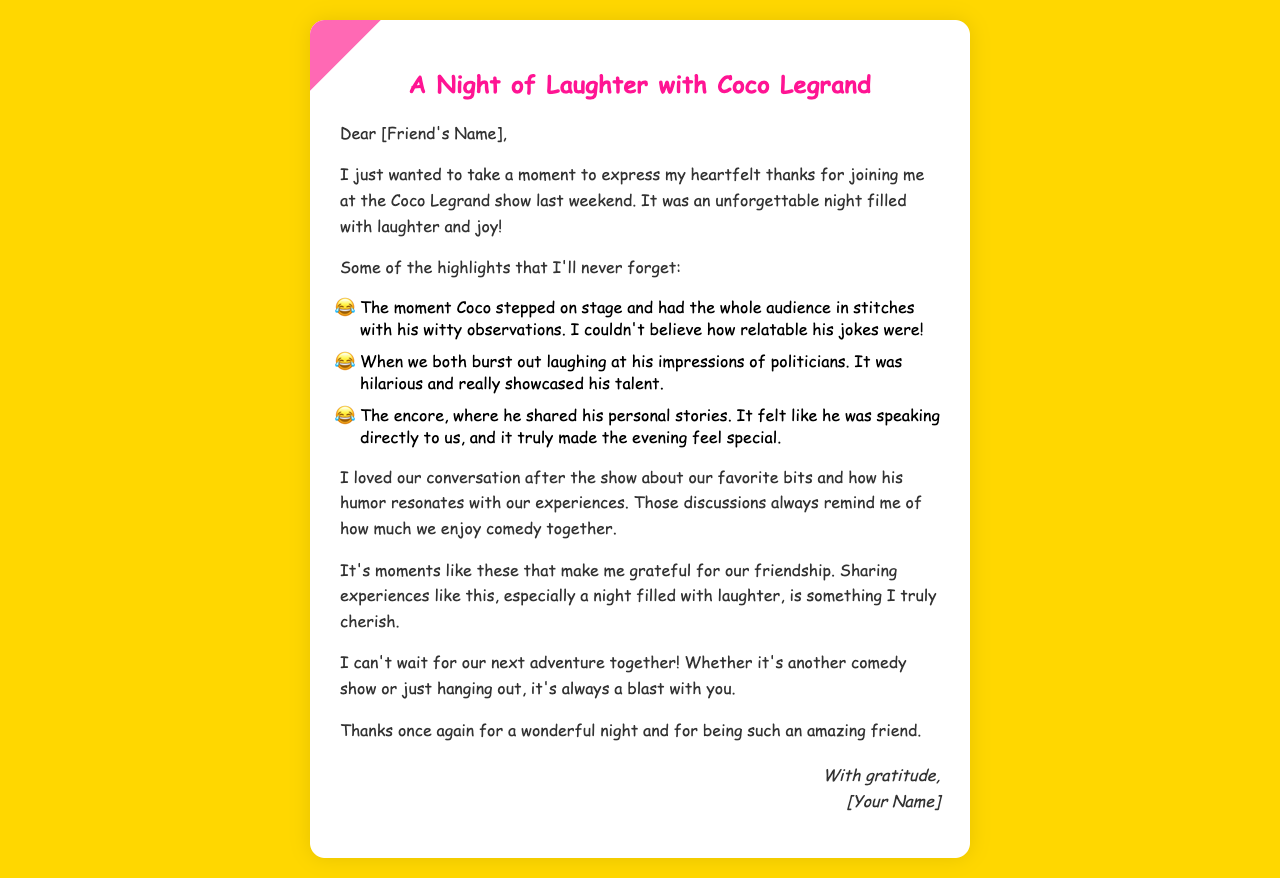What is the title of the letter? The title of the letter is stated at the top of the document.
Answer: A Night of Laughter with Coco Legrand Who is the letter addressed to? The letter is addressed to a specific friend by placeholder name.
Answer: [Friend's Name] What was the occasion for the letter? The occasion is described as a memorable event that the sender and the friend attended together.
Answer: Coco Legrand show What was one of the highlights mentioned in the letter? The letter lists specific moments that stood out during the show.
Answer: Coco stepped on stage What emotion is expressed toward the end of the letter? The letter conveys a specific positive sentiment about friendship and shared experiences.
Answer: Gratitude What is the author's sign-off? The ending of the letter includes a specific phrase to conclude it politely.
Answer: With gratitude How did the audience react to Coco's jokes? The document mentions the response of the audience to Coco's performance.
Answer: In stitches What did the author mention about future plans? The author expresses anticipation for an upcoming shared activity.
Answer: Next adventure together What style of humor does the author indicate they appreciate? The letter emphasizes the type of comedy that resonates with the author and their friend.
Answer: Relatable 